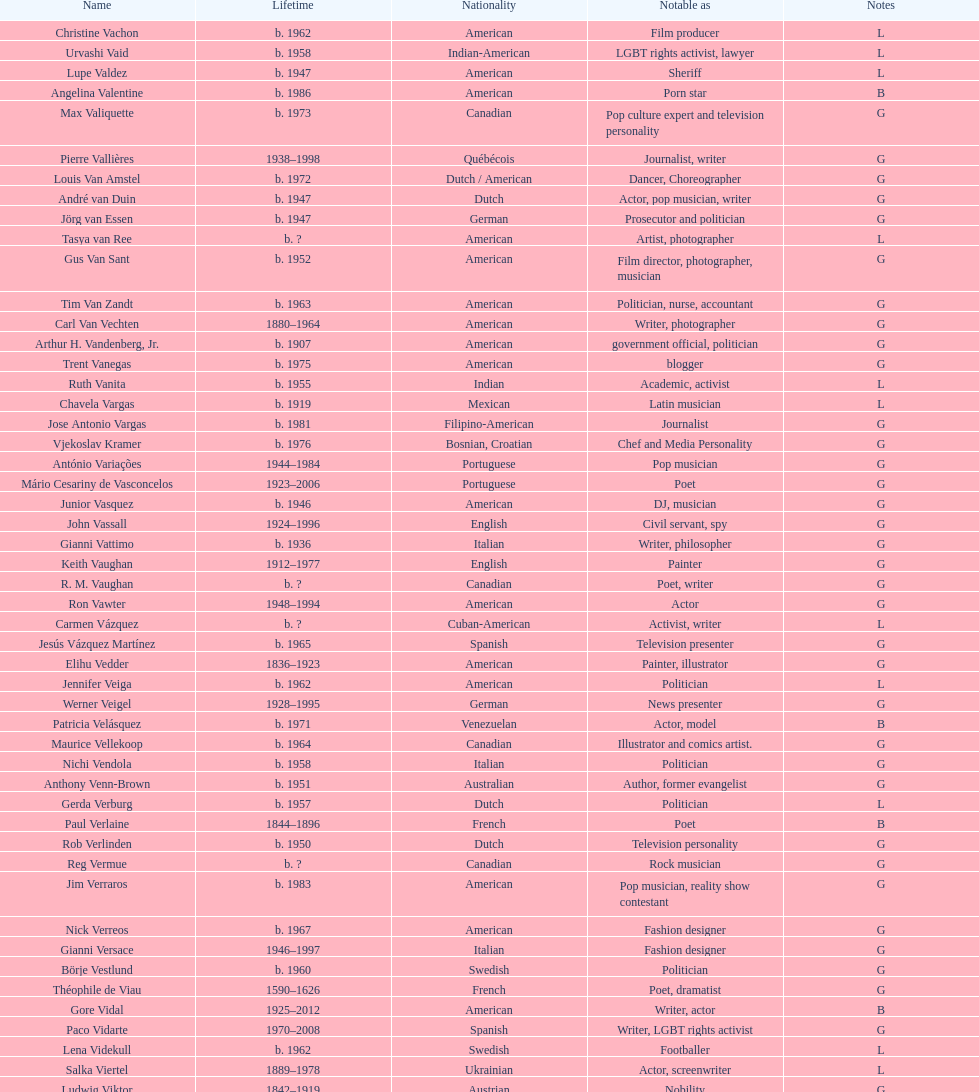Which nationality had the larger amount of names listed? American. 